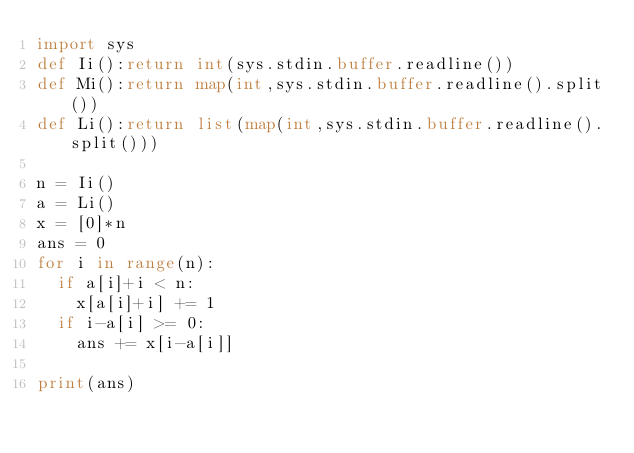Convert code to text. <code><loc_0><loc_0><loc_500><loc_500><_Python_>import sys
def Ii():return int(sys.stdin.buffer.readline())
def Mi():return map(int,sys.stdin.buffer.readline().split())
def Li():return list(map(int,sys.stdin.buffer.readline().split()))

n = Ii()
a = Li()
x = [0]*n
ans = 0
for i in range(n): 
  if a[i]+i < n:
    x[a[i]+i] += 1
  if i-a[i] >= 0:
    ans += x[i-a[i]]
      
print(ans)</code> 